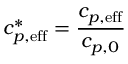Convert formula to latex. <formula><loc_0><loc_0><loc_500><loc_500>c _ { p , e f f } ^ { * } = \frac { c _ { p , e f f } } { c _ { p , 0 } }</formula> 